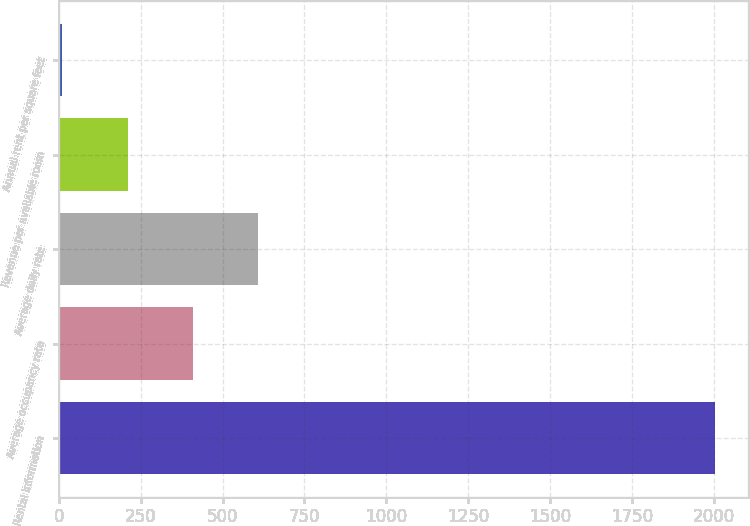Convert chart. <chart><loc_0><loc_0><loc_500><loc_500><bar_chart><fcel>Rental information<fcel>Average occupancy rate<fcel>Average daily rate<fcel>Revenue per available room<fcel>Annual rent per square feet<nl><fcel>2004<fcel>408.84<fcel>608.24<fcel>209.44<fcel>10.04<nl></chart> 